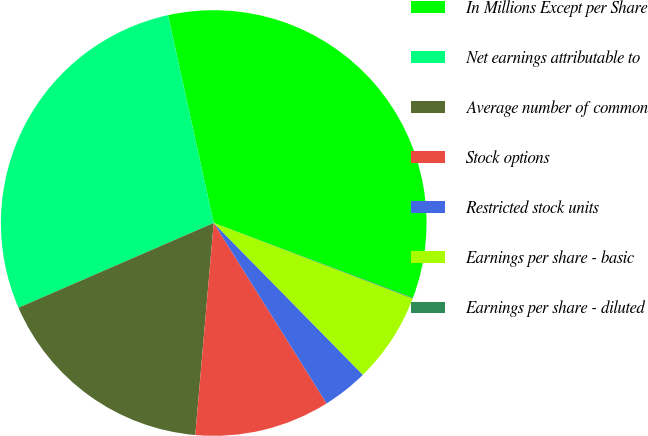Convert chart. <chart><loc_0><loc_0><loc_500><loc_500><pie_chart><fcel>In Millions Except per Share<fcel>Net earnings attributable to<fcel>Average number of common<fcel>Stock options<fcel>Restricted stock units<fcel>Earnings per share - basic<fcel>Earnings per share - diluted<nl><fcel>34.16%<fcel>28.07%<fcel>17.1%<fcel>10.28%<fcel>3.46%<fcel>6.87%<fcel>0.05%<nl></chart> 